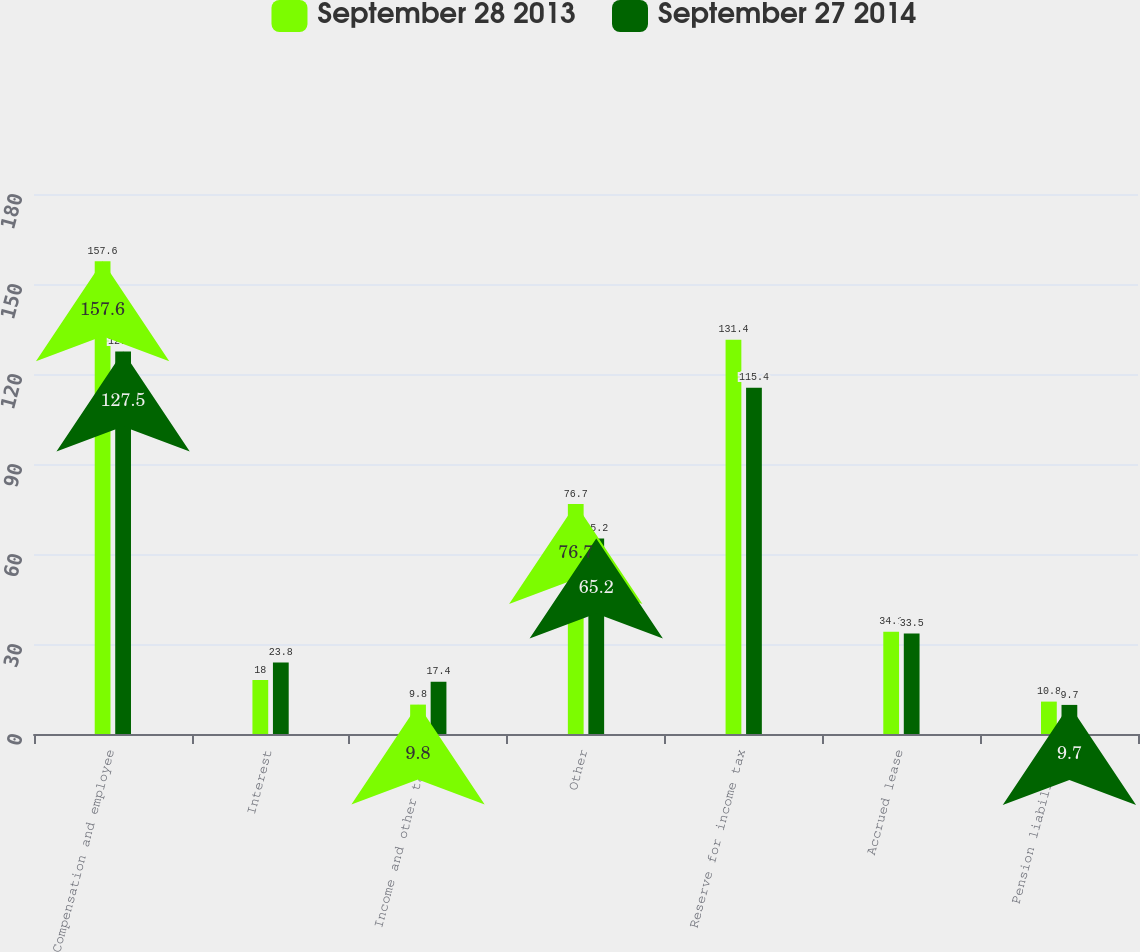Convert chart to OTSL. <chart><loc_0><loc_0><loc_500><loc_500><stacked_bar_chart><ecel><fcel>Compensation and employee<fcel>Interest<fcel>Income and other taxes<fcel>Other<fcel>Reserve for income tax<fcel>Accrued lease<fcel>Pension liabilities<nl><fcel>September 28 2013<fcel>157.6<fcel>18<fcel>9.8<fcel>76.7<fcel>131.4<fcel>34.1<fcel>10.8<nl><fcel>September 27 2014<fcel>127.5<fcel>23.8<fcel>17.4<fcel>65.2<fcel>115.4<fcel>33.5<fcel>9.7<nl></chart> 